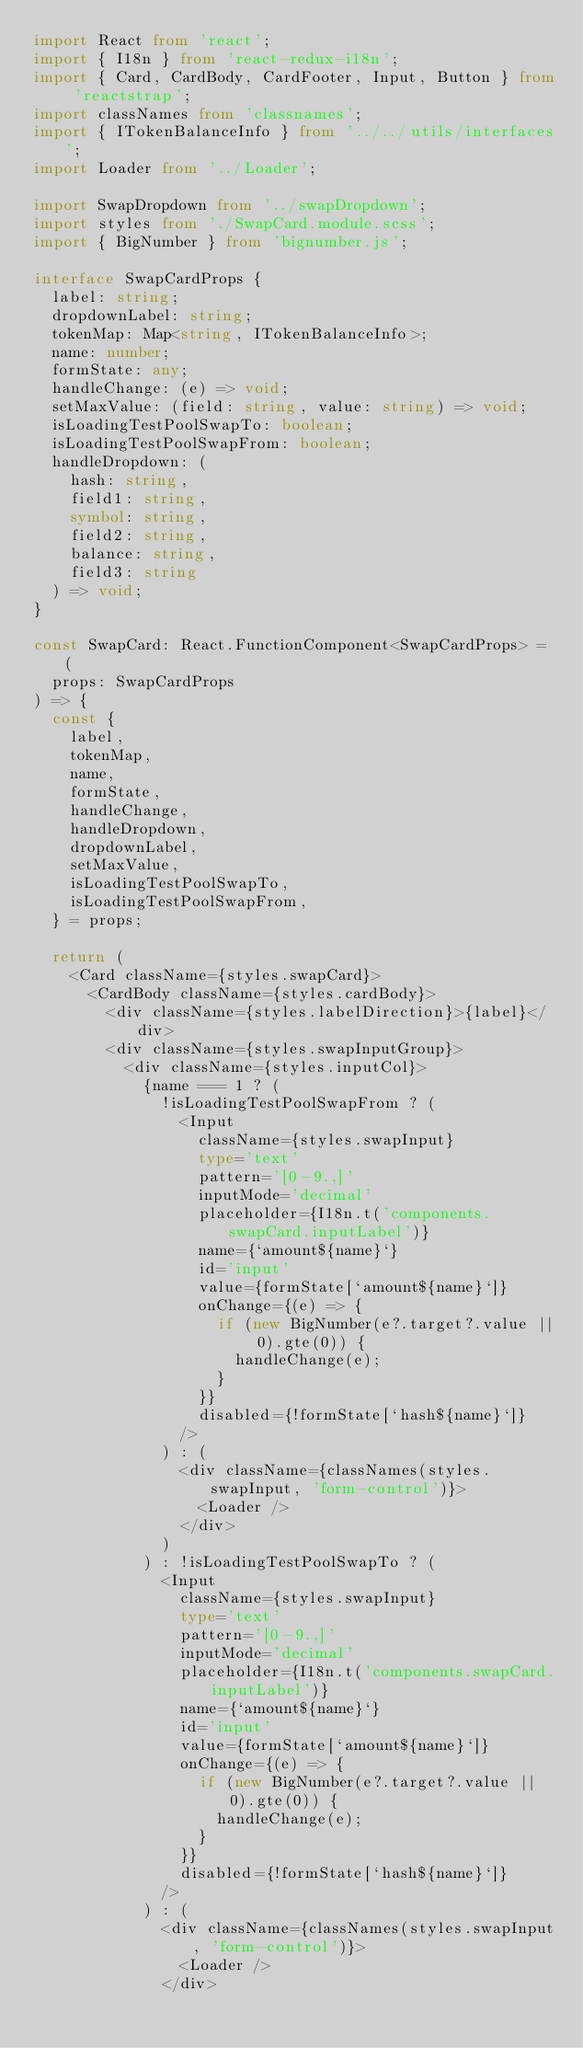<code> <loc_0><loc_0><loc_500><loc_500><_TypeScript_>import React from 'react';
import { I18n } from 'react-redux-i18n';
import { Card, CardBody, CardFooter, Input, Button } from 'reactstrap';
import classNames from 'classnames';
import { ITokenBalanceInfo } from '../../utils/interfaces';
import Loader from '../Loader';

import SwapDropdown from '../swapDropdown';
import styles from './SwapCard.module.scss';
import { BigNumber } from 'bignumber.js';

interface SwapCardProps {
  label: string;
  dropdownLabel: string;
  tokenMap: Map<string, ITokenBalanceInfo>;
  name: number;
  formState: any;
  handleChange: (e) => void;
  setMaxValue: (field: string, value: string) => void;
  isLoadingTestPoolSwapTo: boolean;
  isLoadingTestPoolSwapFrom: boolean;
  handleDropdown: (
    hash: string,
    field1: string,
    symbol: string,
    field2: string,
    balance: string,
    field3: string
  ) => void;
}

const SwapCard: React.FunctionComponent<SwapCardProps> = (
  props: SwapCardProps
) => {
  const {
    label,
    tokenMap,
    name,
    formState,
    handleChange,
    handleDropdown,
    dropdownLabel,
    setMaxValue,
    isLoadingTestPoolSwapTo,
    isLoadingTestPoolSwapFrom,
  } = props;

  return (
    <Card className={styles.swapCard}>
      <CardBody className={styles.cardBody}>
        <div className={styles.labelDirection}>{label}</div>
        <div className={styles.swapInputGroup}>
          <div className={styles.inputCol}>
            {name === 1 ? (
              !isLoadingTestPoolSwapFrom ? (
                <Input
                  className={styles.swapInput}
                  type='text'
                  pattern='[0-9.,]'
                  inputMode='decimal'
                  placeholder={I18n.t('components.swapCard.inputLabel')}
                  name={`amount${name}`}
                  id='input'
                  value={formState[`amount${name}`]}
                  onChange={(e) => {
                    if (new BigNumber(e?.target?.value || 0).gte(0)) {
                      handleChange(e);
                    }
                  }}
                  disabled={!formState[`hash${name}`]}
                />
              ) : (
                <div className={classNames(styles.swapInput, 'form-control')}>
                  <Loader />
                </div>
              )
            ) : !isLoadingTestPoolSwapTo ? (
              <Input
                className={styles.swapInput}
                type='text'
                pattern='[0-9.,]'
                inputMode='decimal'
                placeholder={I18n.t('components.swapCard.inputLabel')}
                name={`amount${name}`}
                id='input'
                value={formState[`amount${name}`]}
                onChange={(e) => {
                  if (new BigNumber(e?.target?.value || 0).gte(0)) {
                    handleChange(e);
                  }
                }}
                disabled={!formState[`hash${name}`]}
              />
            ) : (
              <div className={classNames(styles.swapInput, 'form-control')}>
                <Loader />
              </div></code> 